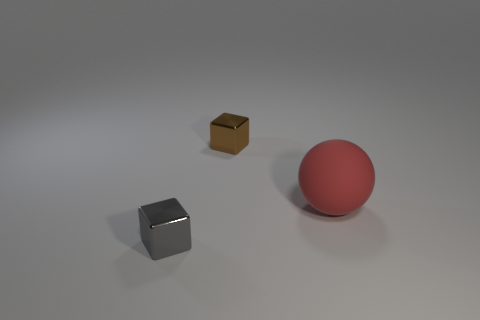Subtract 1 blocks. How many blocks are left? 1 Subtract all purple blocks. How many purple balls are left? 0 Add 2 big red matte objects. How many big red matte objects are left? 3 Add 1 tiny cyan metal balls. How many tiny cyan metal balls exist? 1 Add 1 tiny shiny things. How many objects exist? 4 Subtract all gray blocks. How many blocks are left? 1 Subtract 0 cyan cylinders. How many objects are left? 3 Subtract all blocks. How many objects are left? 1 Subtract all green cubes. Subtract all gray cylinders. How many cubes are left? 2 Subtract all big red objects. Subtract all big blue rubber objects. How many objects are left? 2 